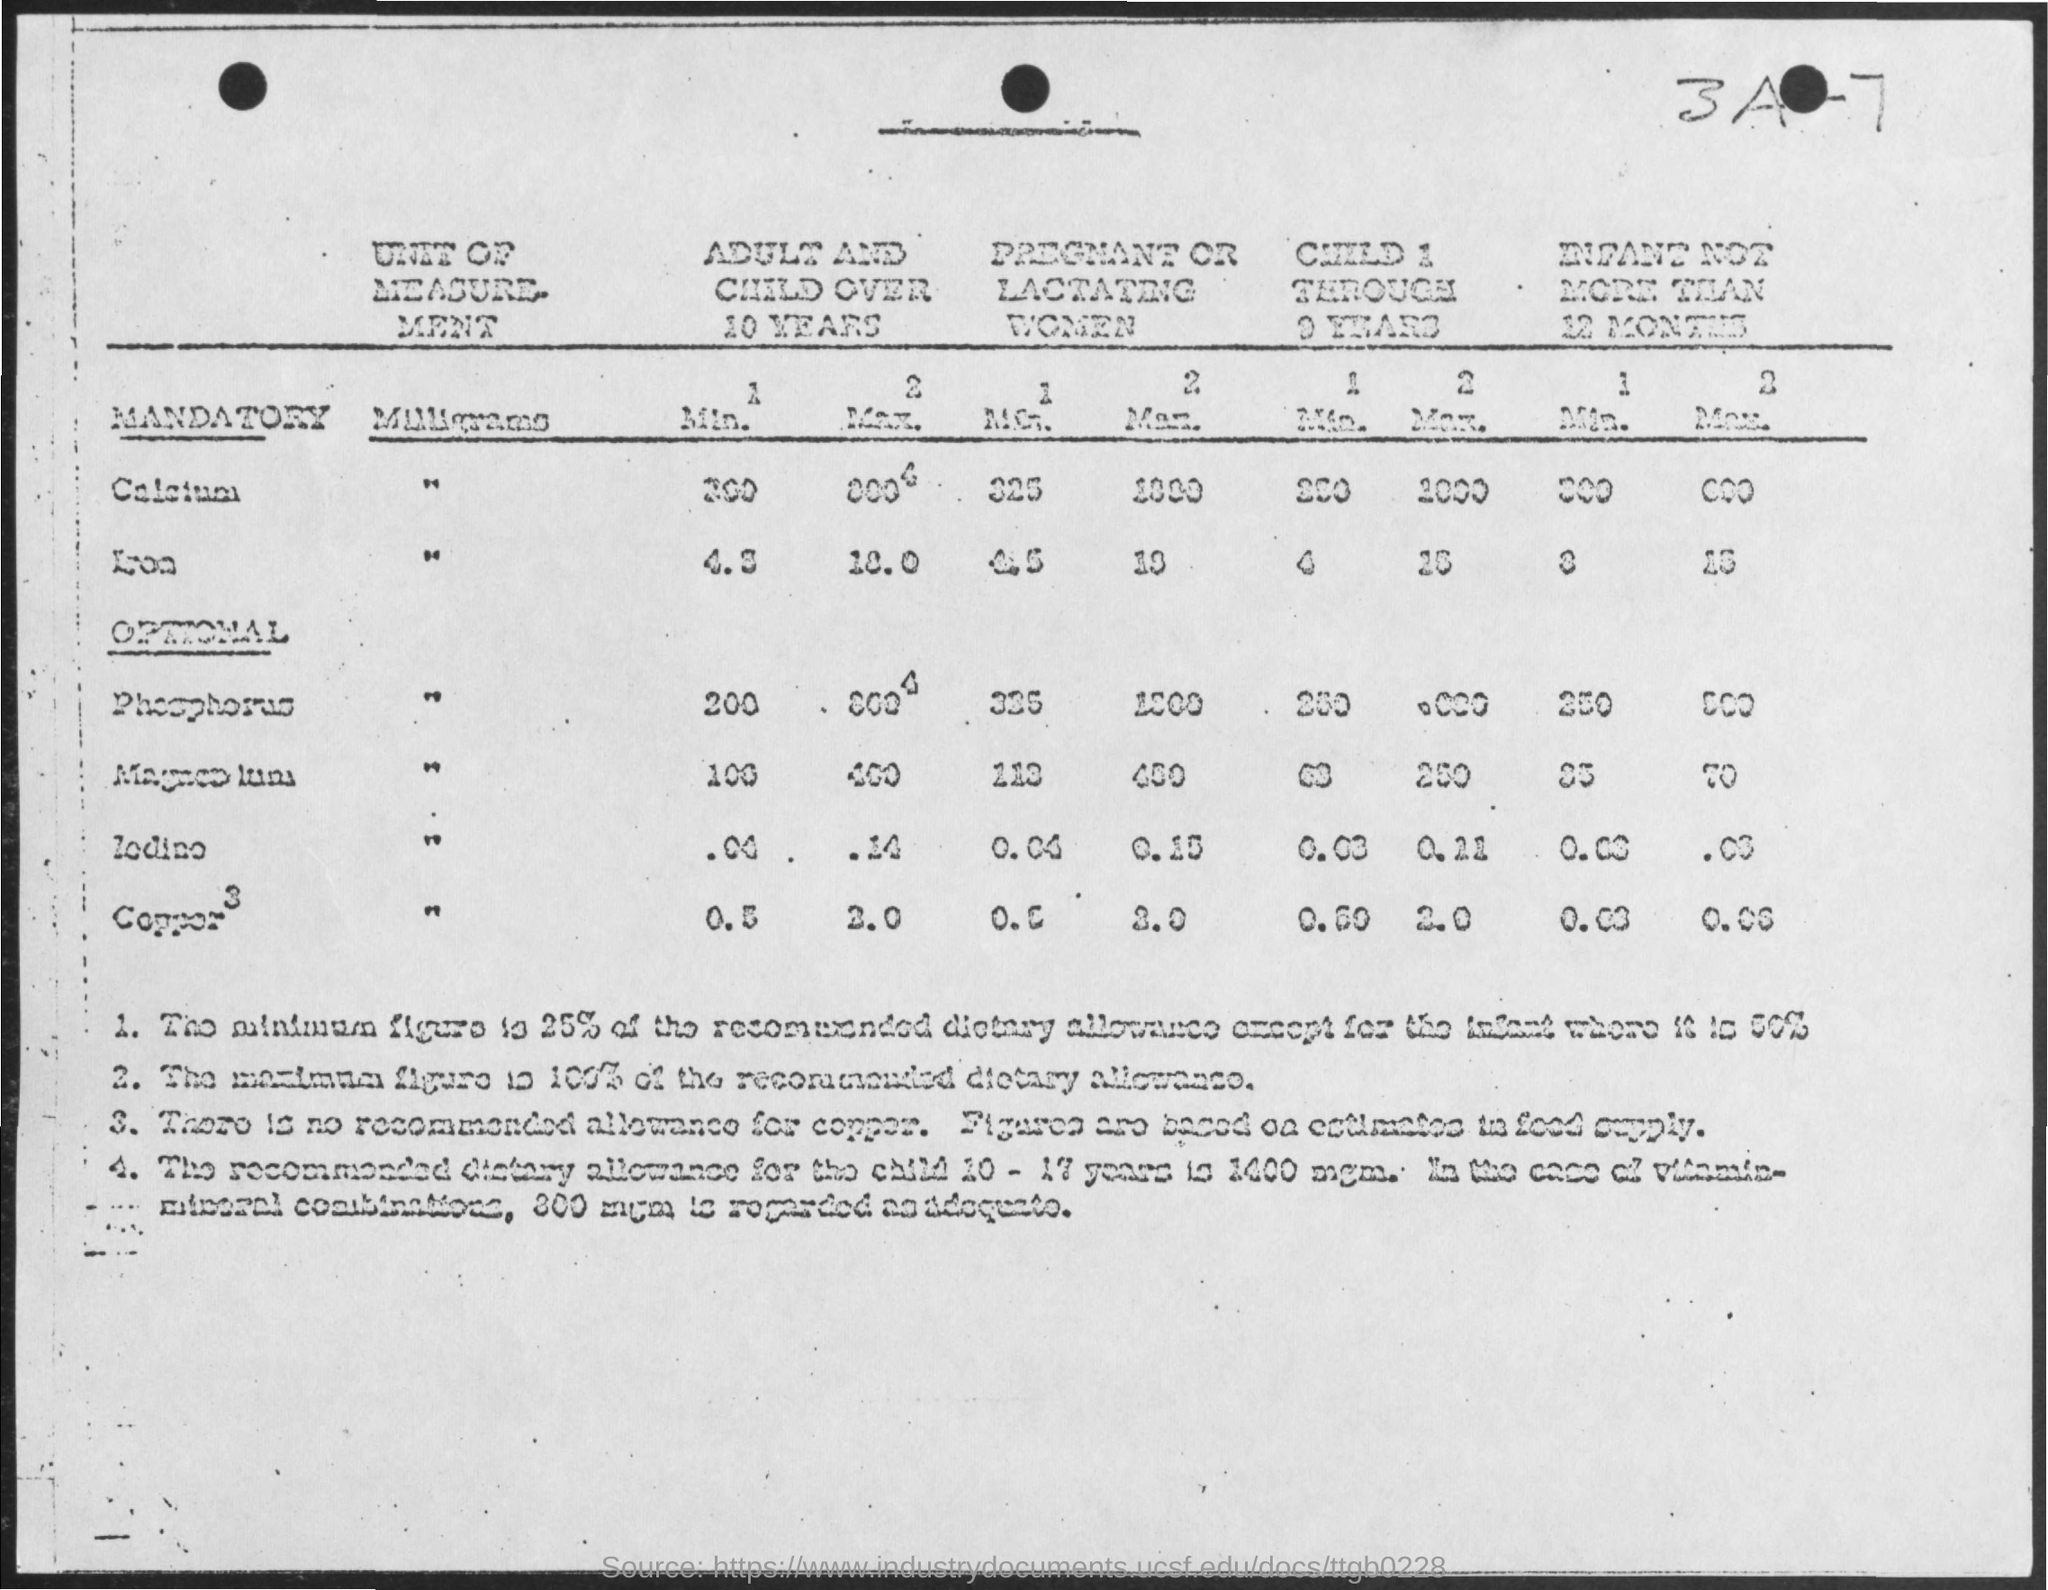Identify some key points in this picture. The top right corner contains the number 3a-7. 